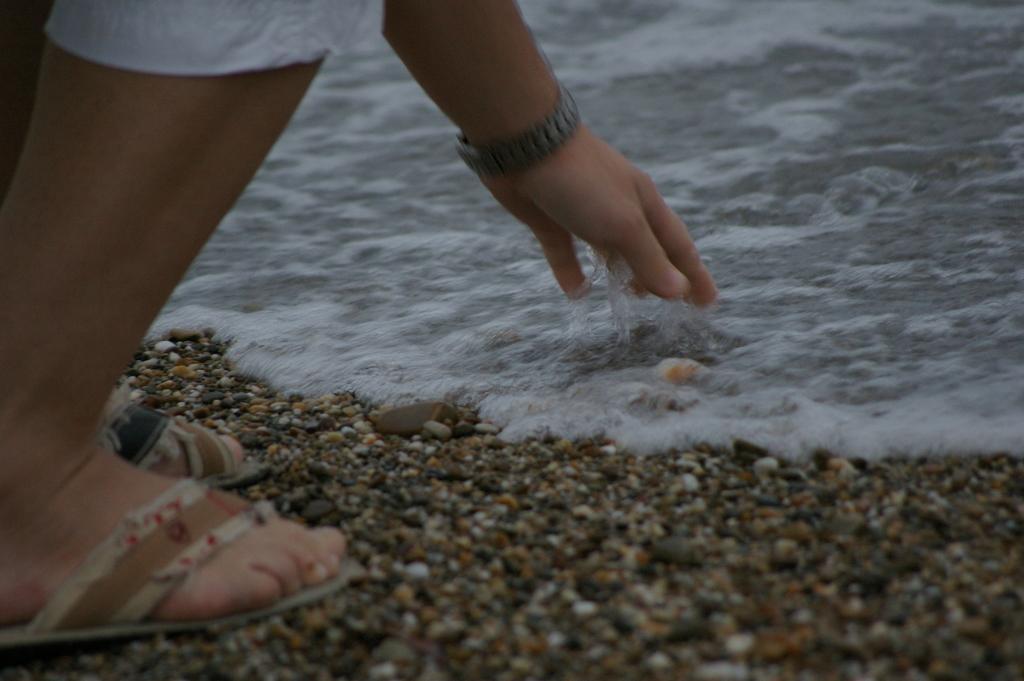How would you summarize this image in a sentence or two? In this picture there is a person standing. At the bottom there is water and there are pebbles. 